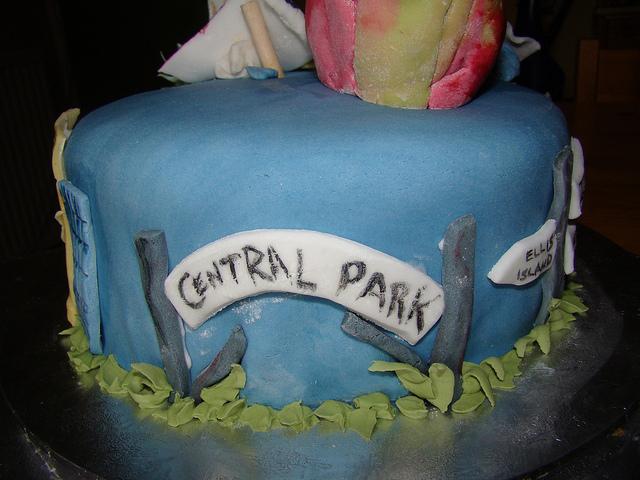What color is the main part of the cake?
Quick response, please. Blue. Would you know the cake had a Central Park theme if it didn't say Central Park?
Keep it brief. No. What is written in the cake?
Give a very brief answer. Central park. 